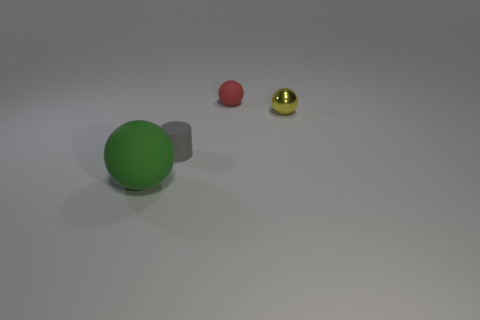Add 2 tiny shiny spheres. How many objects exist? 6 Subtract all large green spheres. Subtract all tiny yellow metal things. How many objects are left? 2 Add 1 small red things. How many small red things are left? 2 Add 2 small red objects. How many small red objects exist? 3 Subtract 1 green balls. How many objects are left? 3 Subtract all balls. How many objects are left? 1 